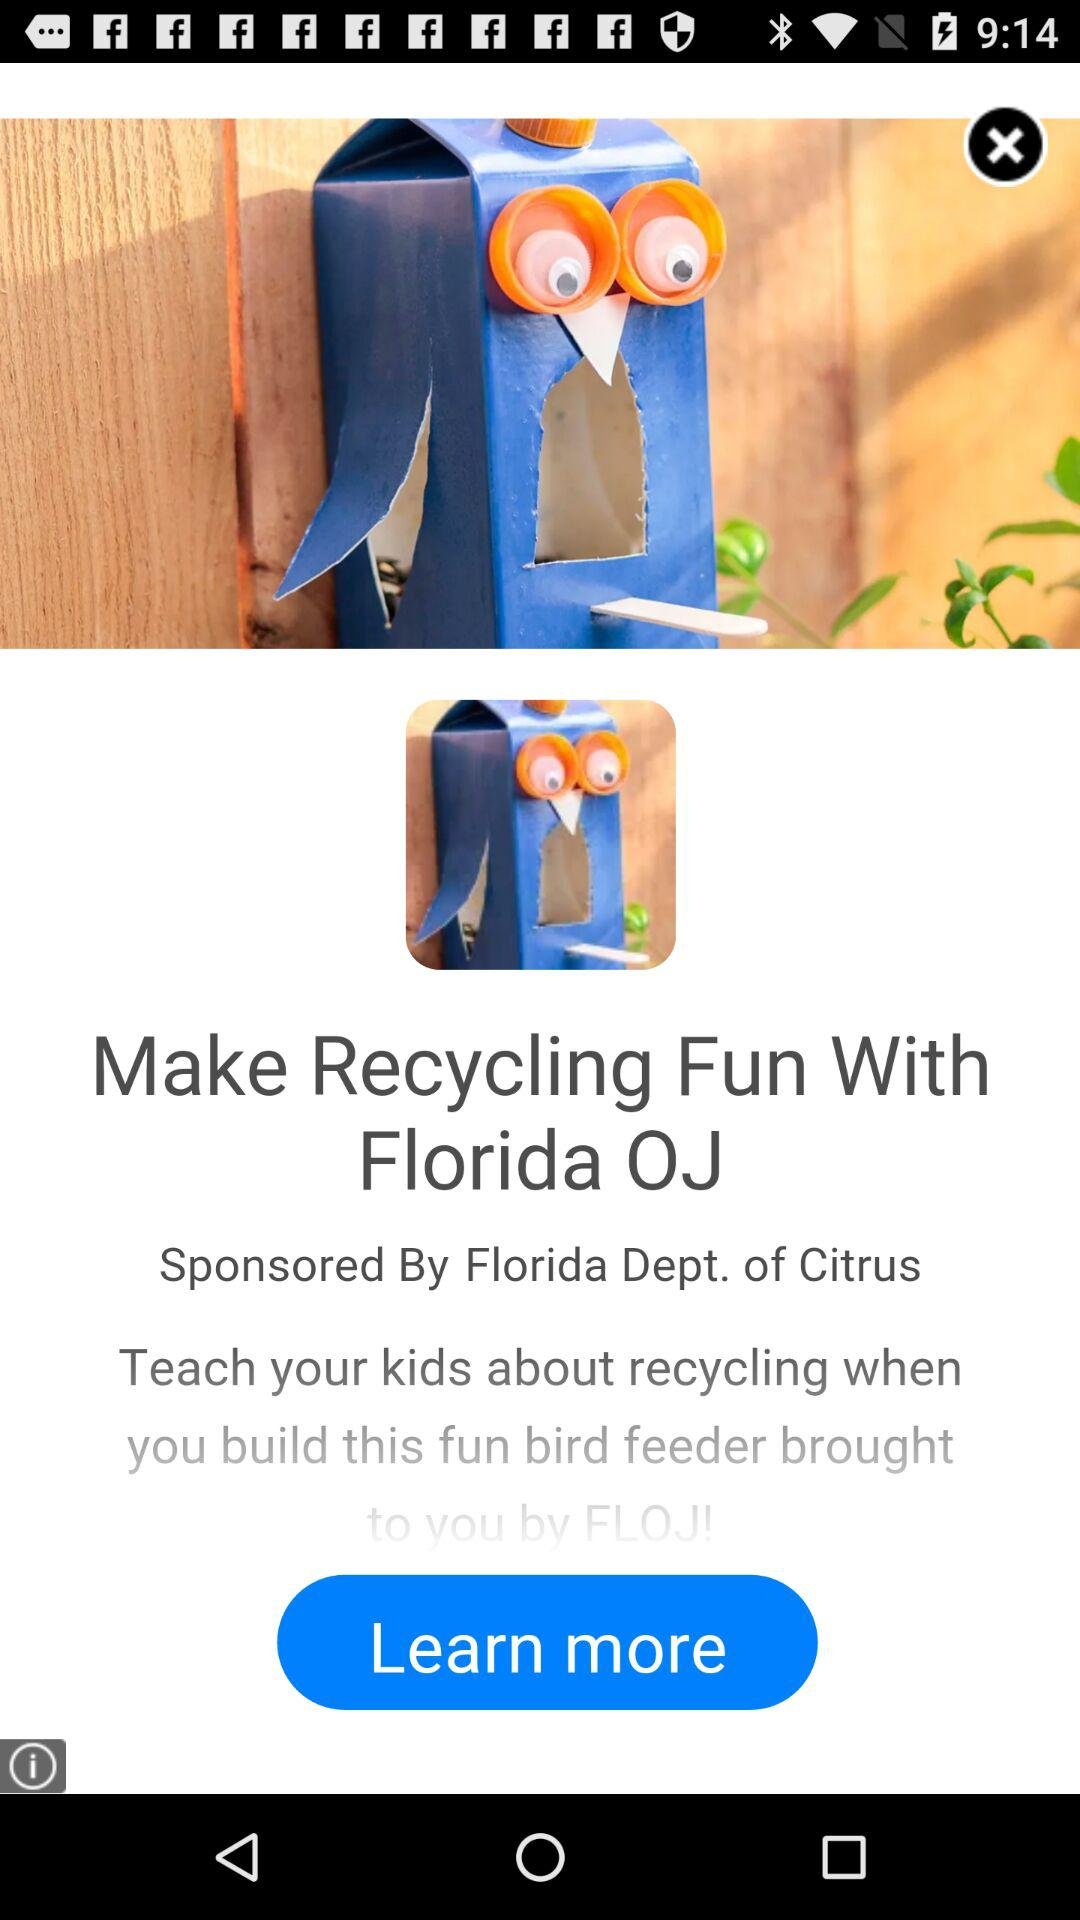How can we contact the Florida Department of Citrus by email?
When the provided information is insufficient, respond with <no answer>. <no answer> 